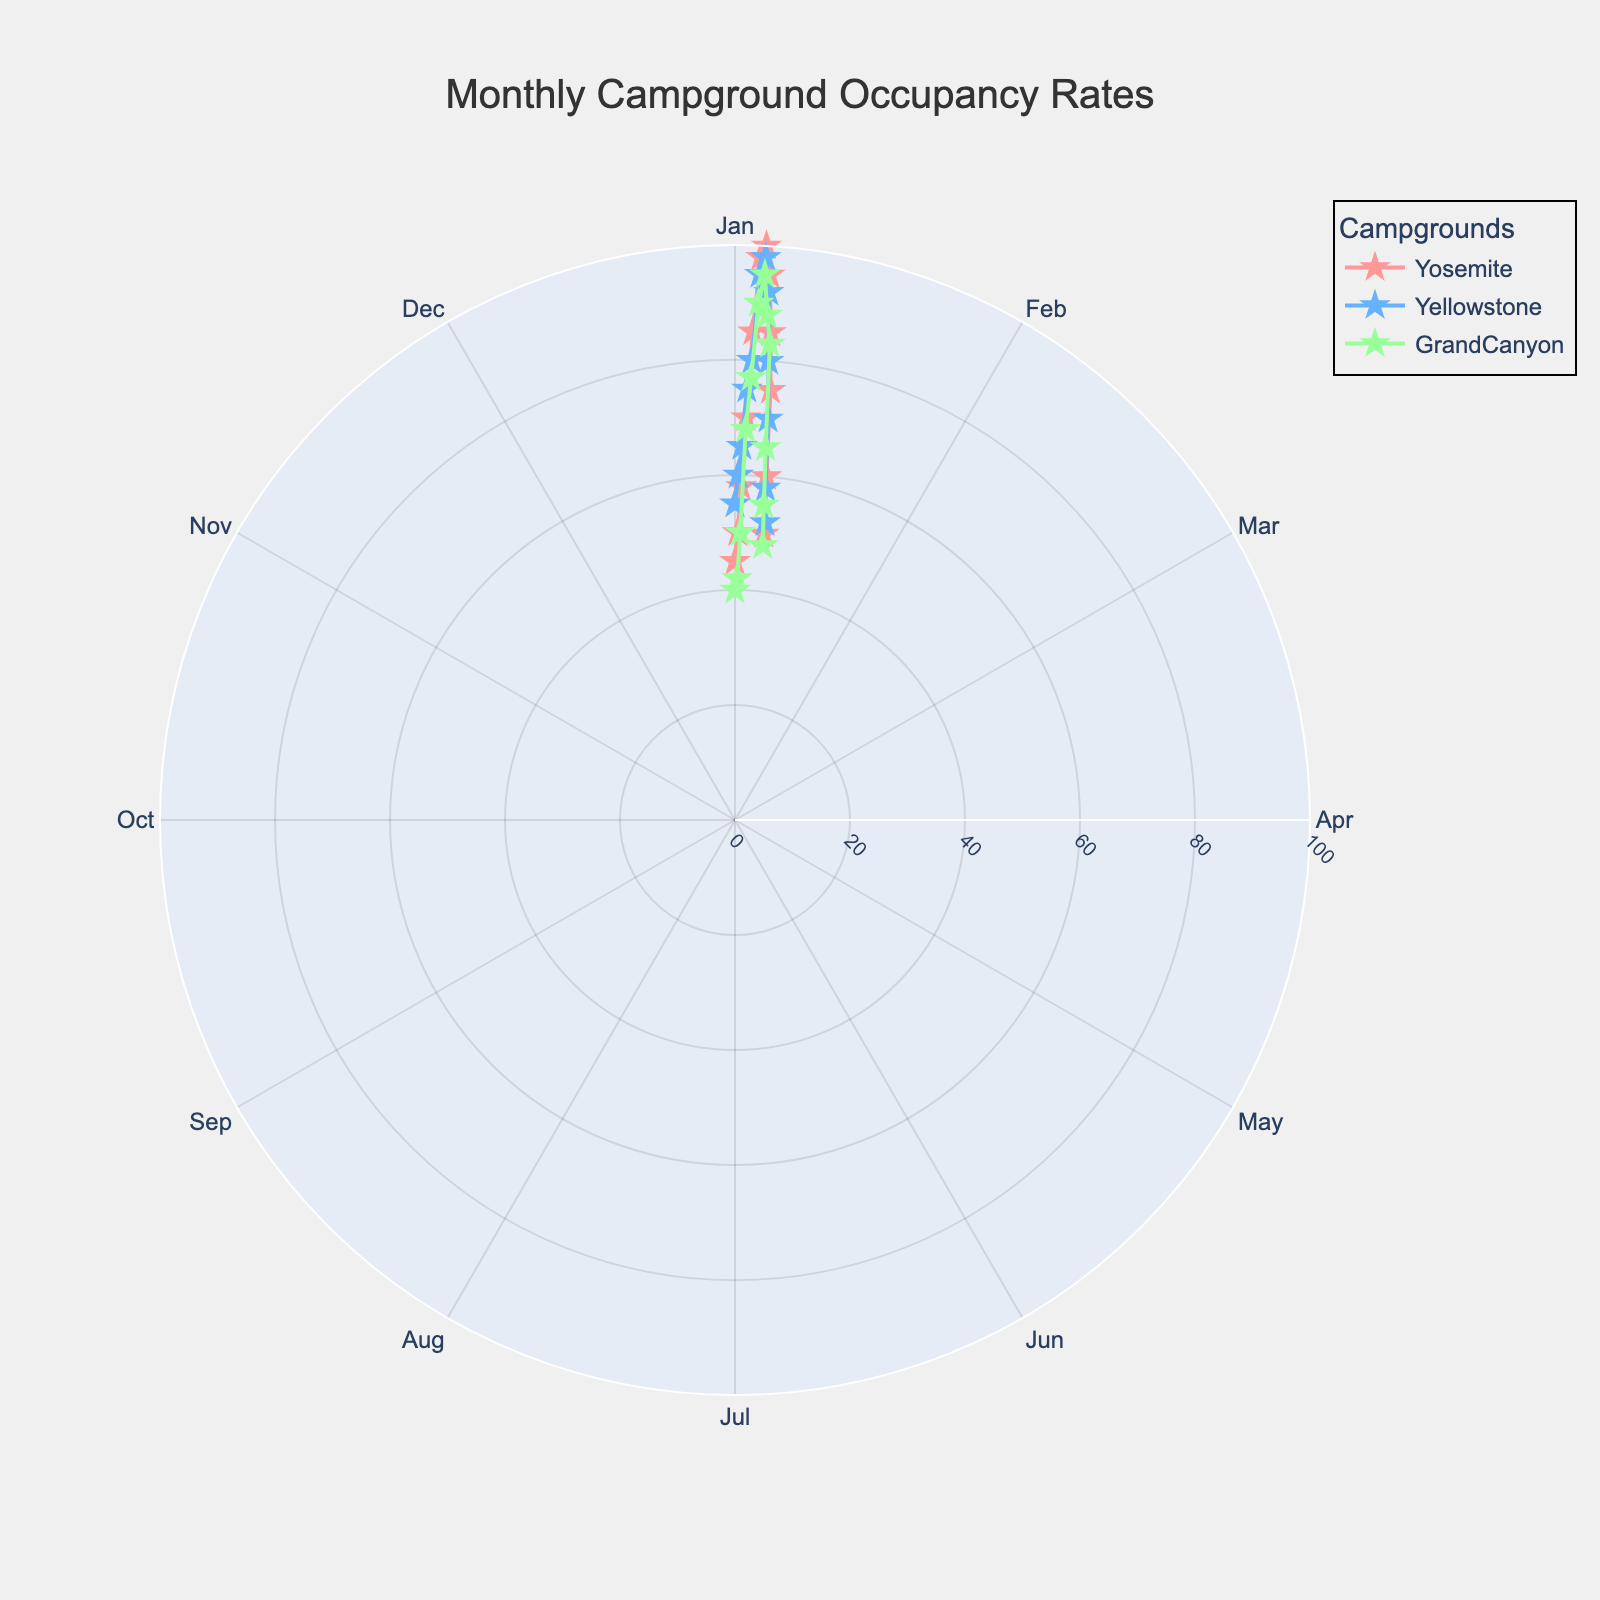What is the title of the figure? The title of the figure is displayed at the top center of the chart, clearly showing what the figure represents.
Answer: Monthly Campground Occupancy Rates How many campgrounds are represented in the figure? By observing the legend or the different colored lines and markers within the chart, you can identify the number of distinct campgrounds.
Answer: Three Which month shows the highest overall occupancy rates? Considering all campgrounds, identify the month where each campground reaches its peak occupancy rate.
Answer: July Which campground has the lowest occupancy rate in December? Look at December’s (theta = 11*30 degrees) data points and compare the occupancy rates for Yosemite, Yellowstone, and Grand Canyon campgrounds.
Answer: Grand Canyon What is the average occupancy rate of Yosemite campground in the summer months (June, July, August)? Locate the points for Yosemite in June, July, and August, sum their occupancy rates (98+100+95), and divide by the number of months (3).
Answer: 97.67 In which month is Yosemite’s campground occupancy rate exactly equal to 70%? By checking the radial (occupancy rate) values around the chart, locate the month where Yosemite is marked at 70%.
Answer: April Which campground shows the least variation in occupancy rates? By examining the spread of the radial lines for each campground, identify the one with the least variation between their highest and lowest rates.
Answer: Yellowstone During which month do all three campgrounds have an occupancy rate greater than 90%? Compare each campground's occupancy rate across the months and find the one where all three exceed 90%.
Answer: July How does the seasonality of Grand Canyon’s occupancy compare to Yosemite’s? Inspect the radial patterns for both campgrounds; generally, identify the season or period each campground peaks and drops. Specifically note the higher and lower periods.
Answer: Both campgrounds peak in summer (July) and have lower rates in winter (January and December) What is the color used to represent Yellowstone campground? The legend on the chart associates each campground name with a specific color, allowing you to identify which campground is represented by each color.
Answer: Blue 